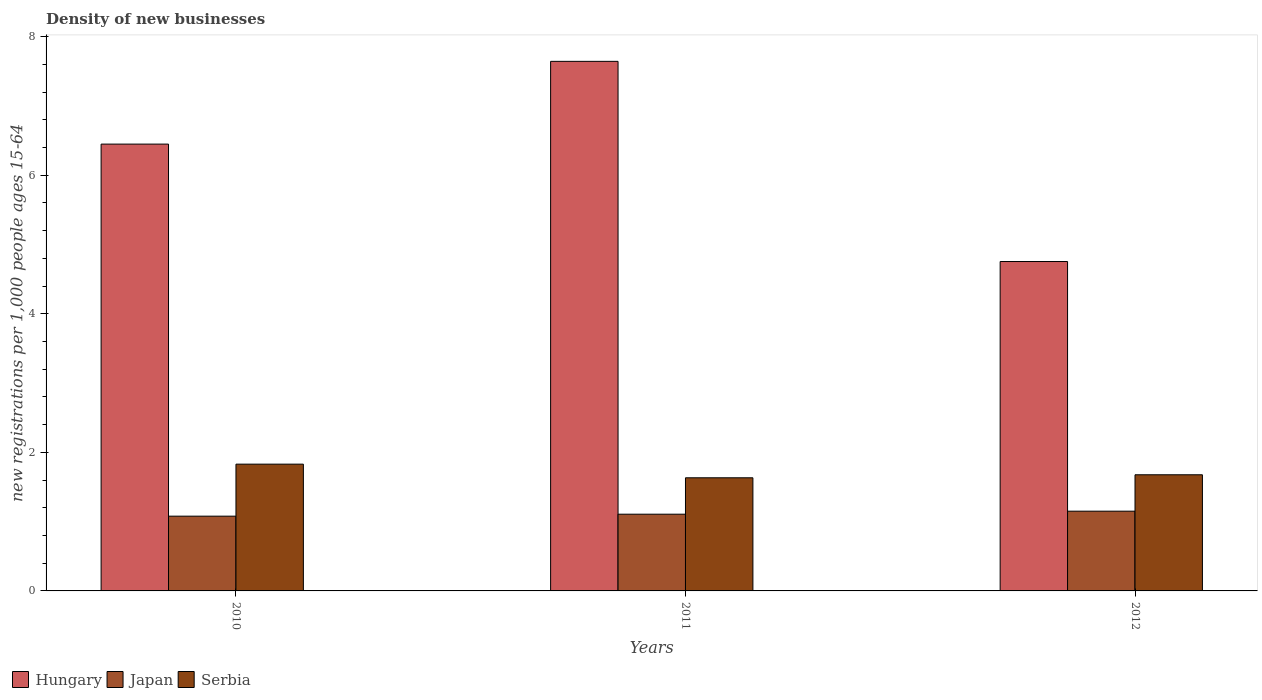How many different coloured bars are there?
Provide a short and direct response. 3. Are the number of bars per tick equal to the number of legend labels?
Ensure brevity in your answer.  Yes. What is the number of new registrations in Hungary in 2011?
Keep it short and to the point. 7.64. Across all years, what is the maximum number of new registrations in Japan?
Your answer should be very brief. 1.15. Across all years, what is the minimum number of new registrations in Serbia?
Ensure brevity in your answer.  1.63. In which year was the number of new registrations in Serbia maximum?
Make the answer very short. 2010. What is the total number of new registrations in Japan in the graph?
Offer a very short reply. 3.34. What is the difference between the number of new registrations in Japan in 2010 and that in 2011?
Keep it short and to the point. -0.03. What is the difference between the number of new registrations in Hungary in 2011 and the number of new registrations in Japan in 2012?
Give a very brief answer. 6.49. What is the average number of new registrations in Japan per year?
Offer a very short reply. 1.11. In the year 2012, what is the difference between the number of new registrations in Serbia and number of new registrations in Japan?
Your answer should be compact. 0.53. In how many years, is the number of new registrations in Hungary greater than 2.4?
Give a very brief answer. 3. What is the ratio of the number of new registrations in Hungary in 2010 to that in 2012?
Keep it short and to the point. 1.36. What is the difference between the highest and the second highest number of new registrations in Serbia?
Your answer should be very brief. 0.15. What is the difference between the highest and the lowest number of new registrations in Serbia?
Give a very brief answer. 0.2. What does the 2nd bar from the left in 2012 represents?
Keep it short and to the point. Japan. What does the 1st bar from the right in 2012 represents?
Make the answer very short. Serbia. Is it the case that in every year, the sum of the number of new registrations in Hungary and number of new registrations in Serbia is greater than the number of new registrations in Japan?
Offer a very short reply. Yes. Are all the bars in the graph horizontal?
Your answer should be very brief. No. How many years are there in the graph?
Provide a short and direct response. 3. What is the difference between two consecutive major ticks on the Y-axis?
Ensure brevity in your answer.  2. Are the values on the major ticks of Y-axis written in scientific E-notation?
Keep it short and to the point. No. Where does the legend appear in the graph?
Offer a terse response. Bottom left. What is the title of the graph?
Offer a terse response. Density of new businesses. What is the label or title of the X-axis?
Your answer should be compact. Years. What is the label or title of the Y-axis?
Keep it short and to the point. New registrations per 1,0 people ages 15-64. What is the new registrations per 1,000 people ages 15-64 of Hungary in 2010?
Give a very brief answer. 6.45. What is the new registrations per 1,000 people ages 15-64 of Japan in 2010?
Your answer should be compact. 1.08. What is the new registrations per 1,000 people ages 15-64 in Serbia in 2010?
Your answer should be very brief. 1.83. What is the new registrations per 1,000 people ages 15-64 of Hungary in 2011?
Your response must be concise. 7.64. What is the new registrations per 1,000 people ages 15-64 of Japan in 2011?
Your response must be concise. 1.11. What is the new registrations per 1,000 people ages 15-64 in Serbia in 2011?
Make the answer very short. 1.63. What is the new registrations per 1,000 people ages 15-64 of Hungary in 2012?
Provide a succinct answer. 4.75. What is the new registrations per 1,000 people ages 15-64 of Japan in 2012?
Provide a short and direct response. 1.15. What is the new registrations per 1,000 people ages 15-64 of Serbia in 2012?
Offer a very short reply. 1.68. Across all years, what is the maximum new registrations per 1,000 people ages 15-64 in Hungary?
Give a very brief answer. 7.64. Across all years, what is the maximum new registrations per 1,000 people ages 15-64 in Japan?
Make the answer very short. 1.15. Across all years, what is the maximum new registrations per 1,000 people ages 15-64 of Serbia?
Ensure brevity in your answer.  1.83. Across all years, what is the minimum new registrations per 1,000 people ages 15-64 in Hungary?
Offer a terse response. 4.75. Across all years, what is the minimum new registrations per 1,000 people ages 15-64 in Japan?
Your response must be concise. 1.08. Across all years, what is the minimum new registrations per 1,000 people ages 15-64 of Serbia?
Give a very brief answer. 1.63. What is the total new registrations per 1,000 people ages 15-64 of Hungary in the graph?
Offer a very short reply. 18.85. What is the total new registrations per 1,000 people ages 15-64 of Japan in the graph?
Your response must be concise. 3.34. What is the total new registrations per 1,000 people ages 15-64 in Serbia in the graph?
Your response must be concise. 5.14. What is the difference between the new registrations per 1,000 people ages 15-64 in Hungary in 2010 and that in 2011?
Your answer should be compact. -1.19. What is the difference between the new registrations per 1,000 people ages 15-64 of Japan in 2010 and that in 2011?
Provide a short and direct response. -0.03. What is the difference between the new registrations per 1,000 people ages 15-64 in Serbia in 2010 and that in 2011?
Your response must be concise. 0.2. What is the difference between the new registrations per 1,000 people ages 15-64 of Hungary in 2010 and that in 2012?
Provide a succinct answer. 1.69. What is the difference between the new registrations per 1,000 people ages 15-64 in Japan in 2010 and that in 2012?
Make the answer very short. -0.07. What is the difference between the new registrations per 1,000 people ages 15-64 in Serbia in 2010 and that in 2012?
Ensure brevity in your answer.  0.15. What is the difference between the new registrations per 1,000 people ages 15-64 of Hungary in 2011 and that in 2012?
Offer a terse response. 2.89. What is the difference between the new registrations per 1,000 people ages 15-64 of Japan in 2011 and that in 2012?
Give a very brief answer. -0.04. What is the difference between the new registrations per 1,000 people ages 15-64 in Serbia in 2011 and that in 2012?
Give a very brief answer. -0.04. What is the difference between the new registrations per 1,000 people ages 15-64 in Hungary in 2010 and the new registrations per 1,000 people ages 15-64 in Japan in 2011?
Provide a short and direct response. 5.34. What is the difference between the new registrations per 1,000 people ages 15-64 of Hungary in 2010 and the new registrations per 1,000 people ages 15-64 of Serbia in 2011?
Your response must be concise. 4.82. What is the difference between the new registrations per 1,000 people ages 15-64 in Japan in 2010 and the new registrations per 1,000 people ages 15-64 in Serbia in 2011?
Give a very brief answer. -0.55. What is the difference between the new registrations per 1,000 people ages 15-64 of Hungary in 2010 and the new registrations per 1,000 people ages 15-64 of Japan in 2012?
Make the answer very short. 5.3. What is the difference between the new registrations per 1,000 people ages 15-64 in Hungary in 2010 and the new registrations per 1,000 people ages 15-64 in Serbia in 2012?
Offer a terse response. 4.77. What is the difference between the new registrations per 1,000 people ages 15-64 of Japan in 2010 and the new registrations per 1,000 people ages 15-64 of Serbia in 2012?
Your response must be concise. -0.6. What is the difference between the new registrations per 1,000 people ages 15-64 of Hungary in 2011 and the new registrations per 1,000 people ages 15-64 of Japan in 2012?
Your answer should be compact. 6.49. What is the difference between the new registrations per 1,000 people ages 15-64 of Hungary in 2011 and the new registrations per 1,000 people ages 15-64 of Serbia in 2012?
Give a very brief answer. 5.97. What is the difference between the new registrations per 1,000 people ages 15-64 of Japan in 2011 and the new registrations per 1,000 people ages 15-64 of Serbia in 2012?
Offer a terse response. -0.57. What is the average new registrations per 1,000 people ages 15-64 of Hungary per year?
Your answer should be compact. 6.28. What is the average new registrations per 1,000 people ages 15-64 of Japan per year?
Give a very brief answer. 1.11. What is the average new registrations per 1,000 people ages 15-64 of Serbia per year?
Offer a terse response. 1.71. In the year 2010, what is the difference between the new registrations per 1,000 people ages 15-64 in Hungary and new registrations per 1,000 people ages 15-64 in Japan?
Keep it short and to the point. 5.37. In the year 2010, what is the difference between the new registrations per 1,000 people ages 15-64 of Hungary and new registrations per 1,000 people ages 15-64 of Serbia?
Offer a terse response. 4.62. In the year 2010, what is the difference between the new registrations per 1,000 people ages 15-64 of Japan and new registrations per 1,000 people ages 15-64 of Serbia?
Ensure brevity in your answer.  -0.75. In the year 2011, what is the difference between the new registrations per 1,000 people ages 15-64 in Hungary and new registrations per 1,000 people ages 15-64 in Japan?
Your answer should be very brief. 6.54. In the year 2011, what is the difference between the new registrations per 1,000 people ages 15-64 of Hungary and new registrations per 1,000 people ages 15-64 of Serbia?
Your response must be concise. 6.01. In the year 2011, what is the difference between the new registrations per 1,000 people ages 15-64 of Japan and new registrations per 1,000 people ages 15-64 of Serbia?
Your answer should be compact. -0.53. In the year 2012, what is the difference between the new registrations per 1,000 people ages 15-64 in Hungary and new registrations per 1,000 people ages 15-64 in Japan?
Your answer should be compact. 3.6. In the year 2012, what is the difference between the new registrations per 1,000 people ages 15-64 of Hungary and new registrations per 1,000 people ages 15-64 of Serbia?
Provide a succinct answer. 3.08. In the year 2012, what is the difference between the new registrations per 1,000 people ages 15-64 of Japan and new registrations per 1,000 people ages 15-64 of Serbia?
Offer a terse response. -0.53. What is the ratio of the new registrations per 1,000 people ages 15-64 in Hungary in 2010 to that in 2011?
Make the answer very short. 0.84. What is the ratio of the new registrations per 1,000 people ages 15-64 in Japan in 2010 to that in 2011?
Keep it short and to the point. 0.97. What is the ratio of the new registrations per 1,000 people ages 15-64 in Serbia in 2010 to that in 2011?
Offer a very short reply. 1.12. What is the ratio of the new registrations per 1,000 people ages 15-64 of Hungary in 2010 to that in 2012?
Offer a very short reply. 1.36. What is the ratio of the new registrations per 1,000 people ages 15-64 in Japan in 2010 to that in 2012?
Your answer should be compact. 0.94. What is the ratio of the new registrations per 1,000 people ages 15-64 of Serbia in 2010 to that in 2012?
Your answer should be compact. 1.09. What is the ratio of the new registrations per 1,000 people ages 15-64 in Hungary in 2011 to that in 2012?
Provide a short and direct response. 1.61. What is the ratio of the new registrations per 1,000 people ages 15-64 of Japan in 2011 to that in 2012?
Keep it short and to the point. 0.96. What is the ratio of the new registrations per 1,000 people ages 15-64 of Serbia in 2011 to that in 2012?
Offer a terse response. 0.97. What is the difference between the highest and the second highest new registrations per 1,000 people ages 15-64 of Hungary?
Offer a terse response. 1.19. What is the difference between the highest and the second highest new registrations per 1,000 people ages 15-64 in Japan?
Provide a short and direct response. 0.04. What is the difference between the highest and the second highest new registrations per 1,000 people ages 15-64 of Serbia?
Your response must be concise. 0.15. What is the difference between the highest and the lowest new registrations per 1,000 people ages 15-64 in Hungary?
Keep it short and to the point. 2.89. What is the difference between the highest and the lowest new registrations per 1,000 people ages 15-64 in Japan?
Ensure brevity in your answer.  0.07. What is the difference between the highest and the lowest new registrations per 1,000 people ages 15-64 of Serbia?
Provide a succinct answer. 0.2. 